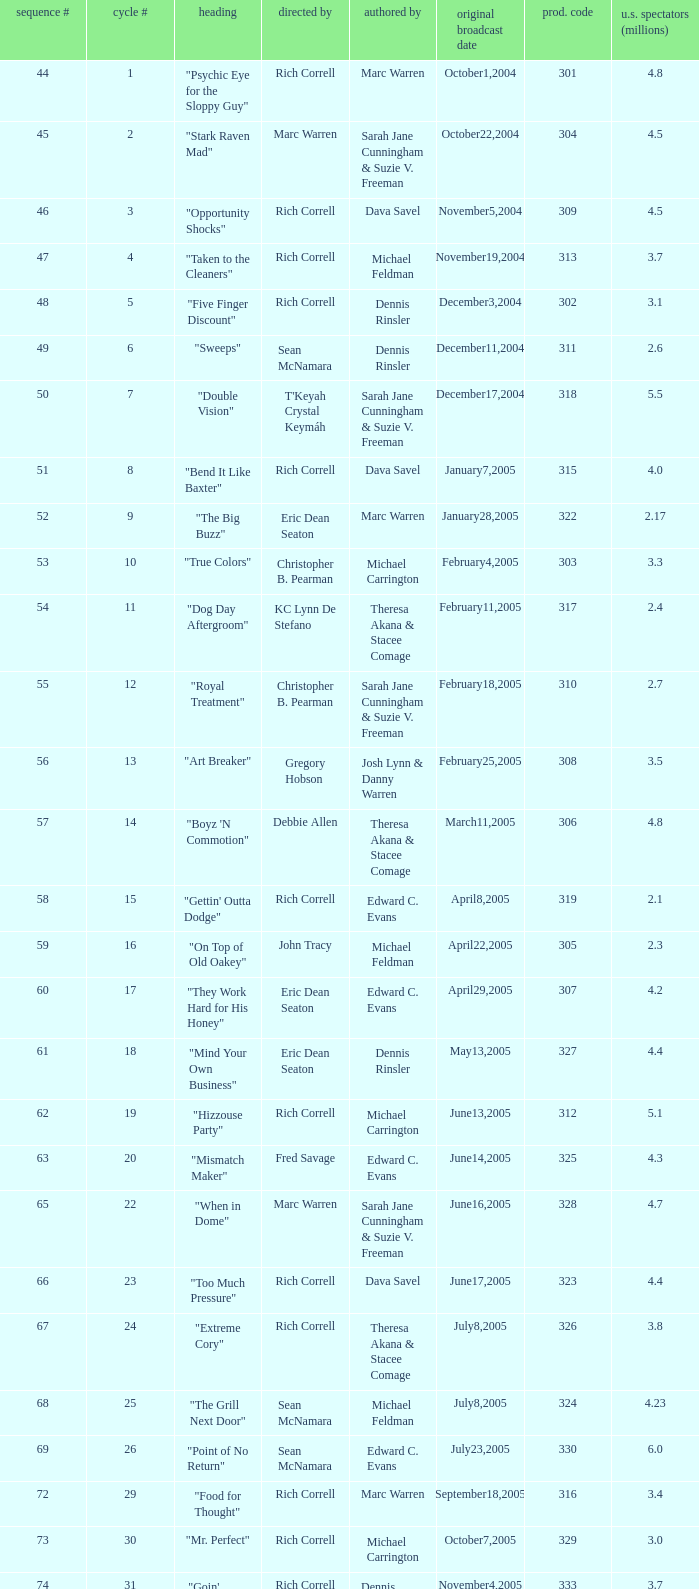What number episode in the season had a production code of 334? 32.0. 